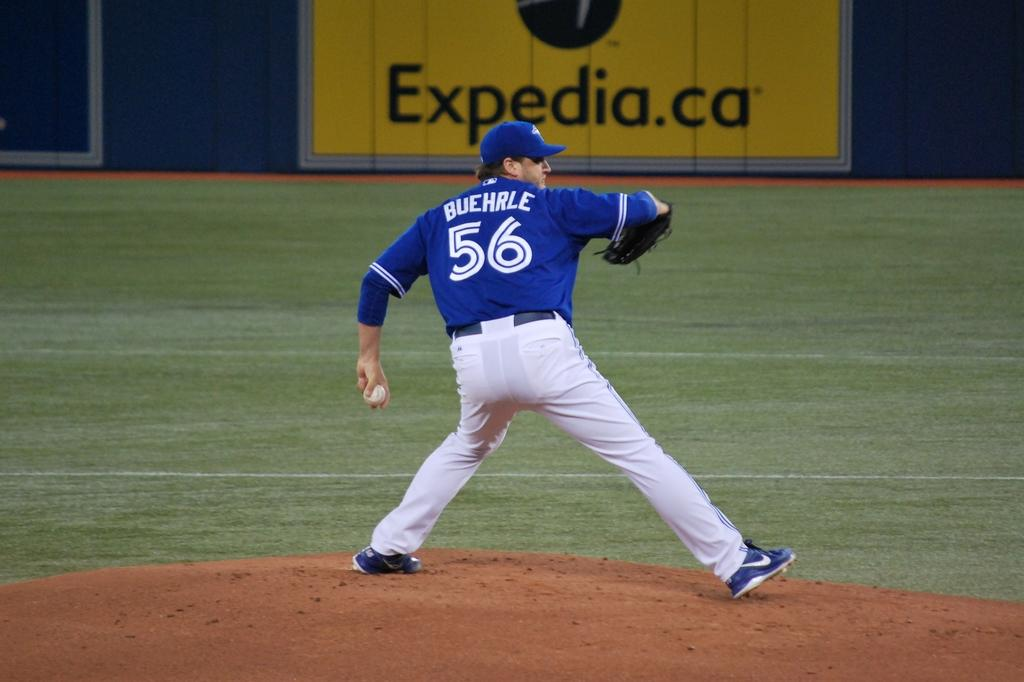<image>
Offer a succinct explanation of the picture presented. Player 56 pitches the ball in front of an Expedia ad. 